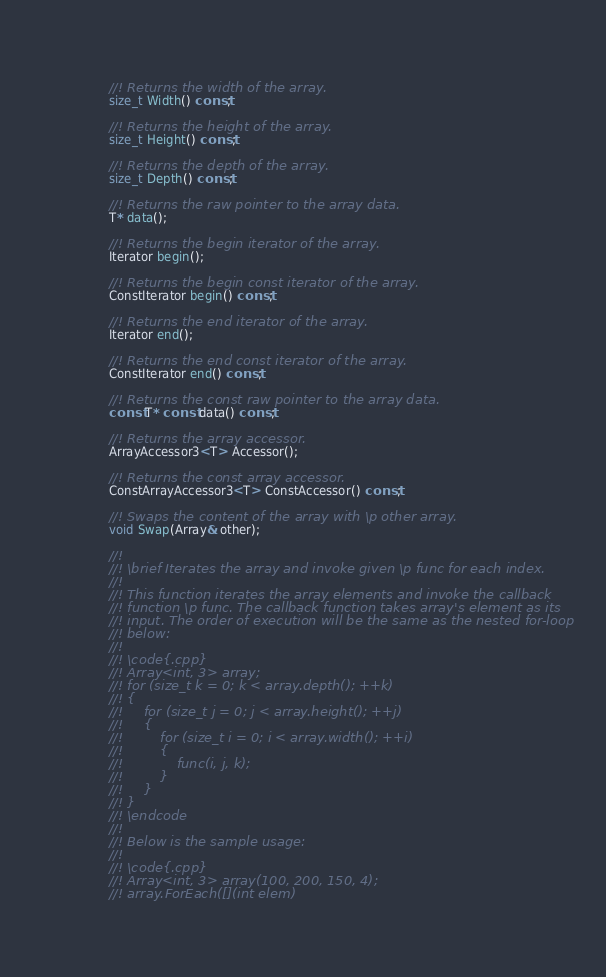<code> <loc_0><loc_0><loc_500><loc_500><_C_>
		//! Returns the width of the array.
		size_t Width() const;

		//! Returns the height of the array.
		size_t Height() const;

		//! Returns the depth of the array.
		size_t Depth() const;

		//! Returns the raw pointer to the array data.
		T* data();

		//! Returns the begin iterator of the array.
		Iterator begin();

		//! Returns the begin const iterator of the array.
		ConstIterator begin() const;

		//! Returns the end iterator of the array.
		Iterator end();

		//! Returns the end const iterator of the array.
		ConstIterator end() const;

		//! Returns the const raw pointer to the array data.
		const T* const data() const;

		//! Returns the array accessor.
		ArrayAccessor3<T> Accessor();

		//! Returns the const array accessor.
		ConstArrayAccessor3<T> ConstAccessor() const;

		//! Swaps the content of the array with \p other array.
		void Swap(Array& other);

		//!
		//! \brief Iterates the array and invoke given \p func for each index.
		//!
		//! This function iterates the array elements and invoke the callback
		//! function \p func. The callback function takes array's element as its
		//! input. The order of execution will be the same as the nested for-loop
		//! below:
		//!
		//! \code{.cpp}
		//! Array<int, 3> array;
		//! for (size_t k = 0; k < array.depth(); ++k)
		//! {
		//!     for (size_t j = 0; j < array.height(); ++j)
		//!     {
		//!         for (size_t i = 0; i < array.width(); ++i)
		//!         {
		//!             func(i, j, k);
		//!         }
		//!     }
		//! }
		//! \endcode
		//!
		//! Below is the sample usage:
		//!
		//! \code{.cpp}
		//! Array<int, 3> array(100, 200, 150, 4);
		//! array.ForEach([](int elem)</code> 